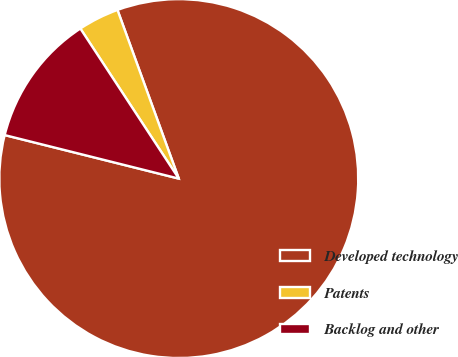<chart> <loc_0><loc_0><loc_500><loc_500><pie_chart><fcel>Developed technology<fcel>Patents<fcel>Backlog and other<nl><fcel>84.44%<fcel>3.69%<fcel>11.86%<nl></chart> 